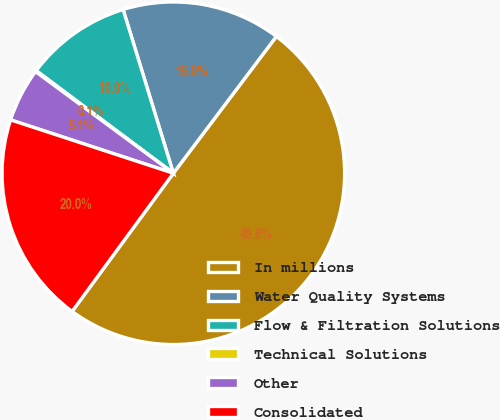Convert chart. <chart><loc_0><loc_0><loc_500><loc_500><pie_chart><fcel>In millions<fcel>Water Quality Systems<fcel>Flow & Filtration Solutions<fcel>Technical Solutions<fcel>Other<fcel>Consolidated<nl><fcel>49.79%<fcel>15.01%<fcel>10.04%<fcel>0.11%<fcel>5.07%<fcel>19.98%<nl></chart> 